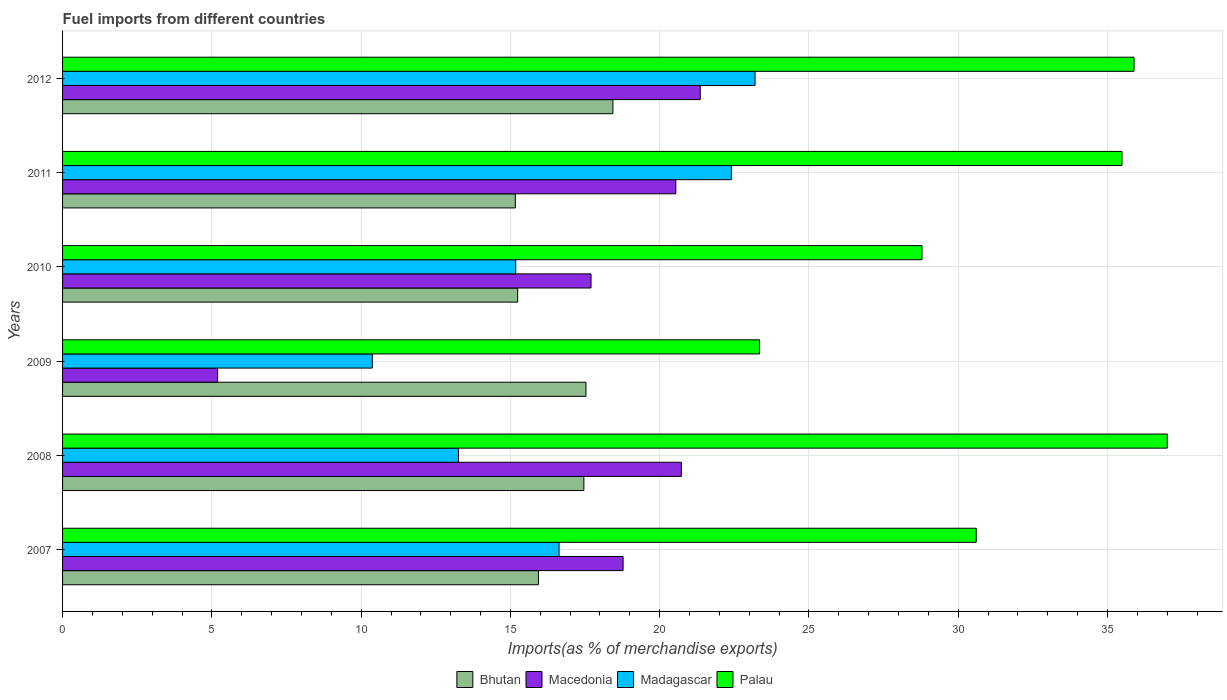Are the number of bars on each tick of the Y-axis equal?
Your answer should be very brief. Yes. In how many cases, is the number of bars for a given year not equal to the number of legend labels?
Offer a very short reply. 0. What is the percentage of imports to different countries in Macedonia in 2012?
Offer a terse response. 21.36. Across all years, what is the maximum percentage of imports to different countries in Bhutan?
Make the answer very short. 18.43. Across all years, what is the minimum percentage of imports to different countries in Bhutan?
Give a very brief answer. 15.16. In which year was the percentage of imports to different countries in Madagascar minimum?
Offer a very short reply. 2009. What is the total percentage of imports to different countries in Madagascar in the graph?
Your response must be concise. 101.04. What is the difference between the percentage of imports to different countries in Madagascar in 2008 and that in 2009?
Provide a short and direct response. 2.89. What is the difference between the percentage of imports to different countries in Bhutan in 2011 and the percentage of imports to different countries in Macedonia in 2012?
Provide a short and direct response. -6.19. What is the average percentage of imports to different countries in Macedonia per year?
Your answer should be compact. 17.38. In the year 2010, what is the difference between the percentage of imports to different countries in Macedonia and percentage of imports to different countries in Madagascar?
Your answer should be compact. 2.52. What is the ratio of the percentage of imports to different countries in Macedonia in 2008 to that in 2010?
Offer a terse response. 1.17. Is the difference between the percentage of imports to different countries in Macedonia in 2009 and 2012 greater than the difference between the percentage of imports to different countries in Madagascar in 2009 and 2012?
Give a very brief answer. No. What is the difference between the highest and the second highest percentage of imports to different countries in Madagascar?
Ensure brevity in your answer.  0.79. What is the difference between the highest and the lowest percentage of imports to different countries in Bhutan?
Offer a very short reply. 3.27. In how many years, is the percentage of imports to different countries in Macedonia greater than the average percentage of imports to different countries in Macedonia taken over all years?
Your response must be concise. 5. Is the sum of the percentage of imports to different countries in Palau in 2008 and 2012 greater than the maximum percentage of imports to different countries in Madagascar across all years?
Your answer should be compact. Yes. Is it the case that in every year, the sum of the percentage of imports to different countries in Bhutan and percentage of imports to different countries in Macedonia is greater than the sum of percentage of imports to different countries in Palau and percentage of imports to different countries in Madagascar?
Your answer should be very brief. No. What does the 2nd bar from the top in 2009 represents?
Your answer should be compact. Madagascar. What does the 4th bar from the bottom in 2009 represents?
Provide a short and direct response. Palau. Is it the case that in every year, the sum of the percentage of imports to different countries in Macedonia and percentage of imports to different countries in Madagascar is greater than the percentage of imports to different countries in Palau?
Offer a very short reply. No. How many bars are there?
Your answer should be very brief. 24. How many years are there in the graph?
Offer a terse response. 6. What is the difference between two consecutive major ticks on the X-axis?
Offer a very short reply. 5. Are the values on the major ticks of X-axis written in scientific E-notation?
Make the answer very short. No. How many legend labels are there?
Your response must be concise. 4. What is the title of the graph?
Make the answer very short. Fuel imports from different countries. Does "Mauritius" appear as one of the legend labels in the graph?
Make the answer very short. No. What is the label or title of the X-axis?
Give a very brief answer. Imports(as % of merchandise exports). What is the label or title of the Y-axis?
Offer a terse response. Years. What is the Imports(as % of merchandise exports) of Bhutan in 2007?
Offer a very short reply. 15.94. What is the Imports(as % of merchandise exports) of Macedonia in 2007?
Give a very brief answer. 18.77. What is the Imports(as % of merchandise exports) in Madagascar in 2007?
Keep it short and to the point. 16.63. What is the Imports(as % of merchandise exports) of Palau in 2007?
Ensure brevity in your answer.  30.6. What is the Imports(as % of merchandise exports) of Bhutan in 2008?
Offer a very short reply. 17.46. What is the Imports(as % of merchandise exports) of Macedonia in 2008?
Ensure brevity in your answer.  20.73. What is the Imports(as % of merchandise exports) of Madagascar in 2008?
Offer a terse response. 13.26. What is the Imports(as % of merchandise exports) of Palau in 2008?
Offer a very short reply. 37. What is the Imports(as % of merchandise exports) in Bhutan in 2009?
Your answer should be very brief. 17.53. What is the Imports(as % of merchandise exports) in Macedonia in 2009?
Offer a terse response. 5.19. What is the Imports(as % of merchandise exports) of Madagascar in 2009?
Offer a terse response. 10.37. What is the Imports(as % of merchandise exports) in Palau in 2009?
Your answer should be compact. 23.34. What is the Imports(as % of merchandise exports) in Bhutan in 2010?
Your answer should be compact. 15.24. What is the Imports(as % of merchandise exports) in Macedonia in 2010?
Give a very brief answer. 17.7. What is the Imports(as % of merchandise exports) of Madagascar in 2010?
Your answer should be very brief. 15.18. What is the Imports(as % of merchandise exports) in Palau in 2010?
Offer a terse response. 28.78. What is the Imports(as % of merchandise exports) of Bhutan in 2011?
Keep it short and to the point. 15.16. What is the Imports(as % of merchandise exports) of Macedonia in 2011?
Your answer should be compact. 20.54. What is the Imports(as % of merchandise exports) of Madagascar in 2011?
Ensure brevity in your answer.  22.4. What is the Imports(as % of merchandise exports) in Palau in 2011?
Offer a very short reply. 35.48. What is the Imports(as % of merchandise exports) in Bhutan in 2012?
Offer a very short reply. 18.43. What is the Imports(as % of merchandise exports) of Macedonia in 2012?
Your response must be concise. 21.36. What is the Imports(as % of merchandise exports) of Madagascar in 2012?
Your answer should be very brief. 23.19. What is the Imports(as % of merchandise exports) in Palau in 2012?
Your answer should be compact. 35.89. Across all years, what is the maximum Imports(as % of merchandise exports) in Bhutan?
Your answer should be very brief. 18.43. Across all years, what is the maximum Imports(as % of merchandise exports) in Macedonia?
Keep it short and to the point. 21.36. Across all years, what is the maximum Imports(as % of merchandise exports) in Madagascar?
Your answer should be compact. 23.19. Across all years, what is the maximum Imports(as % of merchandise exports) in Palau?
Provide a succinct answer. 37. Across all years, what is the minimum Imports(as % of merchandise exports) of Bhutan?
Your answer should be compact. 15.16. Across all years, what is the minimum Imports(as % of merchandise exports) of Macedonia?
Your answer should be compact. 5.19. Across all years, what is the minimum Imports(as % of merchandise exports) in Madagascar?
Keep it short and to the point. 10.37. Across all years, what is the minimum Imports(as % of merchandise exports) of Palau?
Keep it short and to the point. 23.34. What is the total Imports(as % of merchandise exports) in Bhutan in the graph?
Provide a succinct answer. 99.77. What is the total Imports(as % of merchandise exports) of Macedonia in the graph?
Offer a terse response. 104.29. What is the total Imports(as % of merchandise exports) of Madagascar in the graph?
Give a very brief answer. 101.04. What is the total Imports(as % of merchandise exports) in Palau in the graph?
Ensure brevity in your answer.  191.1. What is the difference between the Imports(as % of merchandise exports) in Bhutan in 2007 and that in 2008?
Keep it short and to the point. -1.52. What is the difference between the Imports(as % of merchandise exports) in Macedonia in 2007 and that in 2008?
Your answer should be compact. -1.95. What is the difference between the Imports(as % of merchandise exports) in Madagascar in 2007 and that in 2008?
Your response must be concise. 3.37. What is the difference between the Imports(as % of merchandise exports) in Palau in 2007 and that in 2008?
Provide a succinct answer. -6.4. What is the difference between the Imports(as % of merchandise exports) of Bhutan in 2007 and that in 2009?
Give a very brief answer. -1.59. What is the difference between the Imports(as % of merchandise exports) of Macedonia in 2007 and that in 2009?
Give a very brief answer. 13.58. What is the difference between the Imports(as % of merchandise exports) of Madagascar in 2007 and that in 2009?
Your answer should be very brief. 6.25. What is the difference between the Imports(as % of merchandise exports) in Palau in 2007 and that in 2009?
Your response must be concise. 7.26. What is the difference between the Imports(as % of merchandise exports) of Bhutan in 2007 and that in 2010?
Offer a very short reply. 0.7. What is the difference between the Imports(as % of merchandise exports) in Macedonia in 2007 and that in 2010?
Give a very brief answer. 1.07. What is the difference between the Imports(as % of merchandise exports) of Madagascar in 2007 and that in 2010?
Ensure brevity in your answer.  1.45. What is the difference between the Imports(as % of merchandise exports) of Palau in 2007 and that in 2010?
Offer a very short reply. 1.82. What is the difference between the Imports(as % of merchandise exports) of Bhutan in 2007 and that in 2011?
Make the answer very short. 0.77. What is the difference between the Imports(as % of merchandise exports) in Macedonia in 2007 and that in 2011?
Your answer should be very brief. -1.76. What is the difference between the Imports(as % of merchandise exports) in Madagascar in 2007 and that in 2011?
Offer a terse response. -5.77. What is the difference between the Imports(as % of merchandise exports) of Palau in 2007 and that in 2011?
Ensure brevity in your answer.  -4.88. What is the difference between the Imports(as % of merchandise exports) of Bhutan in 2007 and that in 2012?
Ensure brevity in your answer.  -2.5. What is the difference between the Imports(as % of merchandise exports) of Macedonia in 2007 and that in 2012?
Give a very brief answer. -2.58. What is the difference between the Imports(as % of merchandise exports) of Madagascar in 2007 and that in 2012?
Your response must be concise. -6.56. What is the difference between the Imports(as % of merchandise exports) of Palau in 2007 and that in 2012?
Your answer should be very brief. -5.29. What is the difference between the Imports(as % of merchandise exports) of Bhutan in 2008 and that in 2009?
Offer a terse response. -0.07. What is the difference between the Imports(as % of merchandise exports) of Macedonia in 2008 and that in 2009?
Make the answer very short. 15.53. What is the difference between the Imports(as % of merchandise exports) in Madagascar in 2008 and that in 2009?
Keep it short and to the point. 2.89. What is the difference between the Imports(as % of merchandise exports) of Palau in 2008 and that in 2009?
Your response must be concise. 13.66. What is the difference between the Imports(as % of merchandise exports) in Bhutan in 2008 and that in 2010?
Give a very brief answer. 2.22. What is the difference between the Imports(as % of merchandise exports) in Macedonia in 2008 and that in 2010?
Make the answer very short. 3.03. What is the difference between the Imports(as % of merchandise exports) of Madagascar in 2008 and that in 2010?
Your answer should be very brief. -1.92. What is the difference between the Imports(as % of merchandise exports) in Palau in 2008 and that in 2010?
Provide a succinct answer. 8.21. What is the difference between the Imports(as % of merchandise exports) of Bhutan in 2008 and that in 2011?
Offer a very short reply. 2.3. What is the difference between the Imports(as % of merchandise exports) of Macedonia in 2008 and that in 2011?
Your answer should be very brief. 0.19. What is the difference between the Imports(as % of merchandise exports) of Madagascar in 2008 and that in 2011?
Your answer should be compact. -9.14. What is the difference between the Imports(as % of merchandise exports) of Palau in 2008 and that in 2011?
Ensure brevity in your answer.  1.52. What is the difference between the Imports(as % of merchandise exports) in Bhutan in 2008 and that in 2012?
Provide a short and direct response. -0.97. What is the difference between the Imports(as % of merchandise exports) of Macedonia in 2008 and that in 2012?
Keep it short and to the point. -0.63. What is the difference between the Imports(as % of merchandise exports) in Madagascar in 2008 and that in 2012?
Keep it short and to the point. -9.93. What is the difference between the Imports(as % of merchandise exports) of Palau in 2008 and that in 2012?
Offer a very short reply. 1.11. What is the difference between the Imports(as % of merchandise exports) in Bhutan in 2009 and that in 2010?
Ensure brevity in your answer.  2.29. What is the difference between the Imports(as % of merchandise exports) in Macedonia in 2009 and that in 2010?
Provide a succinct answer. -12.51. What is the difference between the Imports(as % of merchandise exports) in Madagascar in 2009 and that in 2010?
Your answer should be compact. -4.8. What is the difference between the Imports(as % of merchandise exports) of Palau in 2009 and that in 2010?
Your response must be concise. -5.44. What is the difference between the Imports(as % of merchandise exports) in Bhutan in 2009 and that in 2011?
Provide a succinct answer. 2.36. What is the difference between the Imports(as % of merchandise exports) in Macedonia in 2009 and that in 2011?
Ensure brevity in your answer.  -15.35. What is the difference between the Imports(as % of merchandise exports) of Madagascar in 2009 and that in 2011?
Make the answer very short. -12.03. What is the difference between the Imports(as % of merchandise exports) in Palau in 2009 and that in 2011?
Keep it short and to the point. -12.14. What is the difference between the Imports(as % of merchandise exports) of Bhutan in 2009 and that in 2012?
Provide a short and direct response. -0.9. What is the difference between the Imports(as % of merchandise exports) in Macedonia in 2009 and that in 2012?
Provide a short and direct response. -16.16. What is the difference between the Imports(as % of merchandise exports) of Madagascar in 2009 and that in 2012?
Make the answer very short. -12.82. What is the difference between the Imports(as % of merchandise exports) in Palau in 2009 and that in 2012?
Your answer should be very brief. -12.54. What is the difference between the Imports(as % of merchandise exports) in Bhutan in 2010 and that in 2011?
Keep it short and to the point. 0.08. What is the difference between the Imports(as % of merchandise exports) of Macedonia in 2010 and that in 2011?
Provide a short and direct response. -2.84. What is the difference between the Imports(as % of merchandise exports) of Madagascar in 2010 and that in 2011?
Offer a very short reply. -7.22. What is the difference between the Imports(as % of merchandise exports) in Palau in 2010 and that in 2011?
Your response must be concise. -6.7. What is the difference between the Imports(as % of merchandise exports) of Bhutan in 2010 and that in 2012?
Give a very brief answer. -3.19. What is the difference between the Imports(as % of merchandise exports) in Macedonia in 2010 and that in 2012?
Ensure brevity in your answer.  -3.66. What is the difference between the Imports(as % of merchandise exports) of Madagascar in 2010 and that in 2012?
Keep it short and to the point. -8.01. What is the difference between the Imports(as % of merchandise exports) of Palau in 2010 and that in 2012?
Make the answer very short. -7.1. What is the difference between the Imports(as % of merchandise exports) in Bhutan in 2011 and that in 2012?
Provide a succinct answer. -3.27. What is the difference between the Imports(as % of merchandise exports) of Macedonia in 2011 and that in 2012?
Your response must be concise. -0.82. What is the difference between the Imports(as % of merchandise exports) in Madagascar in 2011 and that in 2012?
Keep it short and to the point. -0.79. What is the difference between the Imports(as % of merchandise exports) in Palau in 2011 and that in 2012?
Provide a succinct answer. -0.4. What is the difference between the Imports(as % of merchandise exports) in Bhutan in 2007 and the Imports(as % of merchandise exports) in Macedonia in 2008?
Offer a very short reply. -4.79. What is the difference between the Imports(as % of merchandise exports) in Bhutan in 2007 and the Imports(as % of merchandise exports) in Madagascar in 2008?
Your response must be concise. 2.68. What is the difference between the Imports(as % of merchandise exports) of Bhutan in 2007 and the Imports(as % of merchandise exports) of Palau in 2008?
Give a very brief answer. -21.06. What is the difference between the Imports(as % of merchandise exports) in Macedonia in 2007 and the Imports(as % of merchandise exports) in Madagascar in 2008?
Provide a succinct answer. 5.51. What is the difference between the Imports(as % of merchandise exports) of Macedonia in 2007 and the Imports(as % of merchandise exports) of Palau in 2008?
Offer a very short reply. -18.23. What is the difference between the Imports(as % of merchandise exports) in Madagascar in 2007 and the Imports(as % of merchandise exports) in Palau in 2008?
Give a very brief answer. -20.37. What is the difference between the Imports(as % of merchandise exports) in Bhutan in 2007 and the Imports(as % of merchandise exports) in Macedonia in 2009?
Provide a succinct answer. 10.74. What is the difference between the Imports(as % of merchandise exports) in Bhutan in 2007 and the Imports(as % of merchandise exports) in Madagascar in 2009?
Offer a very short reply. 5.56. What is the difference between the Imports(as % of merchandise exports) in Bhutan in 2007 and the Imports(as % of merchandise exports) in Palau in 2009?
Your response must be concise. -7.41. What is the difference between the Imports(as % of merchandise exports) in Macedonia in 2007 and the Imports(as % of merchandise exports) in Madagascar in 2009?
Provide a succinct answer. 8.4. What is the difference between the Imports(as % of merchandise exports) in Macedonia in 2007 and the Imports(as % of merchandise exports) in Palau in 2009?
Provide a short and direct response. -4.57. What is the difference between the Imports(as % of merchandise exports) of Madagascar in 2007 and the Imports(as % of merchandise exports) of Palau in 2009?
Your answer should be compact. -6.71. What is the difference between the Imports(as % of merchandise exports) in Bhutan in 2007 and the Imports(as % of merchandise exports) in Macedonia in 2010?
Make the answer very short. -1.76. What is the difference between the Imports(as % of merchandise exports) in Bhutan in 2007 and the Imports(as % of merchandise exports) in Madagascar in 2010?
Provide a succinct answer. 0.76. What is the difference between the Imports(as % of merchandise exports) in Bhutan in 2007 and the Imports(as % of merchandise exports) in Palau in 2010?
Give a very brief answer. -12.85. What is the difference between the Imports(as % of merchandise exports) in Macedonia in 2007 and the Imports(as % of merchandise exports) in Madagascar in 2010?
Offer a terse response. 3.6. What is the difference between the Imports(as % of merchandise exports) of Macedonia in 2007 and the Imports(as % of merchandise exports) of Palau in 2010?
Your answer should be compact. -10.01. What is the difference between the Imports(as % of merchandise exports) of Madagascar in 2007 and the Imports(as % of merchandise exports) of Palau in 2010?
Your answer should be very brief. -12.16. What is the difference between the Imports(as % of merchandise exports) in Bhutan in 2007 and the Imports(as % of merchandise exports) in Macedonia in 2011?
Provide a succinct answer. -4.6. What is the difference between the Imports(as % of merchandise exports) of Bhutan in 2007 and the Imports(as % of merchandise exports) of Madagascar in 2011?
Give a very brief answer. -6.46. What is the difference between the Imports(as % of merchandise exports) of Bhutan in 2007 and the Imports(as % of merchandise exports) of Palau in 2011?
Offer a terse response. -19.55. What is the difference between the Imports(as % of merchandise exports) of Macedonia in 2007 and the Imports(as % of merchandise exports) of Madagascar in 2011?
Your answer should be compact. -3.63. What is the difference between the Imports(as % of merchandise exports) in Macedonia in 2007 and the Imports(as % of merchandise exports) in Palau in 2011?
Your answer should be compact. -16.71. What is the difference between the Imports(as % of merchandise exports) of Madagascar in 2007 and the Imports(as % of merchandise exports) of Palau in 2011?
Offer a terse response. -18.85. What is the difference between the Imports(as % of merchandise exports) in Bhutan in 2007 and the Imports(as % of merchandise exports) in Macedonia in 2012?
Make the answer very short. -5.42. What is the difference between the Imports(as % of merchandise exports) of Bhutan in 2007 and the Imports(as % of merchandise exports) of Madagascar in 2012?
Your answer should be very brief. -7.26. What is the difference between the Imports(as % of merchandise exports) of Bhutan in 2007 and the Imports(as % of merchandise exports) of Palau in 2012?
Offer a terse response. -19.95. What is the difference between the Imports(as % of merchandise exports) of Macedonia in 2007 and the Imports(as % of merchandise exports) of Madagascar in 2012?
Give a very brief answer. -4.42. What is the difference between the Imports(as % of merchandise exports) of Macedonia in 2007 and the Imports(as % of merchandise exports) of Palau in 2012?
Offer a terse response. -17.11. What is the difference between the Imports(as % of merchandise exports) of Madagascar in 2007 and the Imports(as % of merchandise exports) of Palau in 2012?
Give a very brief answer. -19.26. What is the difference between the Imports(as % of merchandise exports) of Bhutan in 2008 and the Imports(as % of merchandise exports) of Macedonia in 2009?
Keep it short and to the point. 12.27. What is the difference between the Imports(as % of merchandise exports) of Bhutan in 2008 and the Imports(as % of merchandise exports) of Madagascar in 2009?
Offer a very short reply. 7.09. What is the difference between the Imports(as % of merchandise exports) of Bhutan in 2008 and the Imports(as % of merchandise exports) of Palau in 2009?
Offer a very short reply. -5.88. What is the difference between the Imports(as % of merchandise exports) in Macedonia in 2008 and the Imports(as % of merchandise exports) in Madagascar in 2009?
Your response must be concise. 10.35. What is the difference between the Imports(as % of merchandise exports) of Macedonia in 2008 and the Imports(as % of merchandise exports) of Palau in 2009?
Offer a terse response. -2.62. What is the difference between the Imports(as % of merchandise exports) in Madagascar in 2008 and the Imports(as % of merchandise exports) in Palau in 2009?
Provide a short and direct response. -10.08. What is the difference between the Imports(as % of merchandise exports) of Bhutan in 2008 and the Imports(as % of merchandise exports) of Macedonia in 2010?
Keep it short and to the point. -0.24. What is the difference between the Imports(as % of merchandise exports) in Bhutan in 2008 and the Imports(as % of merchandise exports) in Madagascar in 2010?
Offer a terse response. 2.28. What is the difference between the Imports(as % of merchandise exports) in Bhutan in 2008 and the Imports(as % of merchandise exports) in Palau in 2010?
Provide a succinct answer. -11.32. What is the difference between the Imports(as % of merchandise exports) in Macedonia in 2008 and the Imports(as % of merchandise exports) in Madagascar in 2010?
Provide a succinct answer. 5.55. What is the difference between the Imports(as % of merchandise exports) in Macedonia in 2008 and the Imports(as % of merchandise exports) in Palau in 2010?
Offer a terse response. -8.06. What is the difference between the Imports(as % of merchandise exports) of Madagascar in 2008 and the Imports(as % of merchandise exports) of Palau in 2010?
Provide a short and direct response. -15.52. What is the difference between the Imports(as % of merchandise exports) in Bhutan in 2008 and the Imports(as % of merchandise exports) in Macedonia in 2011?
Offer a very short reply. -3.08. What is the difference between the Imports(as % of merchandise exports) in Bhutan in 2008 and the Imports(as % of merchandise exports) in Madagascar in 2011?
Provide a short and direct response. -4.94. What is the difference between the Imports(as % of merchandise exports) of Bhutan in 2008 and the Imports(as % of merchandise exports) of Palau in 2011?
Your answer should be very brief. -18.02. What is the difference between the Imports(as % of merchandise exports) of Macedonia in 2008 and the Imports(as % of merchandise exports) of Madagascar in 2011?
Give a very brief answer. -1.67. What is the difference between the Imports(as % of merchandise exports) of Macedonia in 2008 and the Imports(as % of merchandise exports) of Palau in 2011?
Provide a short and direct response. -14.76. What is the difference between the Imports(as % of merchandise exports) in Madagascar in 2008 and the Imports(as % of merchandise exports) in Palau in 2011?
Your response must be concise. -22.22. What is the difference between the Imports(as % of merchandise exports) of Bhutan in 2008 and the Imports(as % of merchandise exports) of Macedonia in 2012?
Give a very brief answer. -3.9. What is the difference between the Imports(as % of merchandise exports) of Bhutan in 2008 and the Imports(as % of merchandise exports) of Madagascar in 2012?
Give a very brief answer. -5.73. What is the difference between the Imports(as % of merchandise exports) in Bhutan in 2008 and the Imports(as % of merchandise exports) in Palau in 2012?
Your answer should be compact. -18.43. What is the difference between the Imports(as % of merchandise exports) of Macedonia in 2008 and the Imports(as % of merchandise exports) of Madagascar in 2012?
Offer a terse response. -2.47. What is the difference between the Imports(as % of merchandise exports) in Macedonia in 2008 and the Imports(as % of merchandise exports) in Palau in 2012?
Your answer should be very brief. -15.16. What is the difference between the Imports(as % of merchandise exports) of Madagascar in 2008 and the Imports(as % of merchandise exports) of Palau in 2012?
Ensure brevity in your answer.  -22.63. What is the difference between the Imports(as % of merchandise exports) in Bhutan in 2009 and the Imports(as % of merchandise exports) in Macedonia in 2010?
Offer a terse response. -0.17. What is the difference between the Imports(as % of merchandise exports) in Bhutan in 2009 and the Imports(as % of merchandise exports) in Madagascar in 2010?
Offer a very short reply. 2.35. What is the difference between the Imports(as % of merchandise exports) in Bhutan in 2009 and the Imports(as % of merchandise exports) in Palau in 2010?
Offer a very short reply. -11.26. What is the difference between the Imports(as % of merchandise exports) of Macedonia in 2009 and the Imports(as % of merchandise exports) of Madagascar in 2010?
Ensure brevity in your answer.  -9.98. What is the difference between the Imports(as % of merchandise exports) in Macedonia in 2009 and the Imports(as % of merchandise exports) in Palau in 2010?
Provide a short and direct response. -23.59. What is the difference between the Imports(as % of merchandise exports) of Madagascar in 2009 and the Imports(as % of merchandise exports) of Palau in 2010?
Provide a succinct answer. -18.41. What is the difference between the Imports(as % of merchandise exports) in Bhutan in 2009 and the Imports(as % of merchandise exports) in Macedonia in 2011?
Your answer should be compact. -3.01. What is the difference between the Imports(as % of merchandise exports) of Bhutan in 2009 and the Imports(as % of merchandise exports) of Madagascar in 2011?
Your answer should be compact. -4.87. What is the difference between the Imports(as % of merchandise exports) in Bhutan in 2009 and the Imports(as % of merchandise exports) in Palau in 2011?
Provide a short and direct response. -17.95. What is the difference between the Imports(as % of merchandise exports) of Macedonia in 2009 and the Imports(as % of merchandise exports) of Madagascar in 2011?
Your answer should be compact. -17.21. What is the difference between the Imports(as % of merchandise exports) in Macedonia in 2009 and the Imports(as % of merchandise exports) in Palau in 2011?
Provide a short and direct response. -30.29. What is the difference between the Imports(as % of merchandise exports) of Madagascar in 2009 and the Imports(as % of merchandise exports) of Palau in 2011?
Offer a very short reply. -25.11. What is the difference between the Imports(as % of merchandise exports) of Bhutan in 2009 and the Imports(as % of merchandise exports) of Macedonia in 2012?
Keep it short and to the point. -3.83. What is the difference between the Imports(as % of merchandise exports) of Bhutan in 2009 and the Imports(as % of merchandise exports) of Madagascar in 2012?
Ensure brevity in your answer.  -5.66. What is the difference between the Imports(as % of merchandise exports) of Bhutan in 2009 and the Imports(as % of merchandise exports) of Palau in 2012?
Offer a terse response. -18.36. What is the difference between the Imports(as % of merchandise exports) in Macedonia in 2009 and the Imports(as % of merchandise exports) in Madagascar in 2012?
Your response must be concise. -18. What is the difference between the Imports(as % of merchandise exports) in Macedonia in 2009 and the Imports(as % of merchandise exports) in Palau in 2012?
Provide a short and direct response. -30.69. What is the difference between the Imports(as % of merchandise exports) in Madagascar in 2009 and the Imports(as % of merchandise exports) in Palau in 2012?
Make the answer very short. -25.51. What is the difference between the Imports(as % of merchandise exports) of Bhutan in 2010 and the Imports(as % of merchandise exports) of Macedonia in 2011?
Offer a terse response. -5.3. What is the difference between the Imports(as % of merchandise exports) in Bhutan in 2010 and the Imports(as % of merchandise exports) in Madagascar in 2011?
Offer a terse response. -7.16. What is the difference between the Imports(as % of merchandise exports) in Bhutan in 2010 and the Imports(as % of merchandise exports) in Palau in 2011?
Provide a succinct answer. -20.24. What is the difference between the Imports(as % of merchandise exports) of Macedonia in 2010 and the Imports(as % of merchandise exports) of Madagascar in 2011?
Your answer should be very brief. -4.7. What is the difference between the Imports(as % of merchandise exports) of Macedonia in 2010 and the Imports(as % of merchandise exports) of Palau in 2011?
Provide a short and direct response. -17.78. What is the difference between the Imports(as % of merchandise exports) in Madagascar in 2010 and the Imports(as % of merchandise exports) in Palau in 2011?
Offer a very short reply. -20.3. What is the difference between the Imports(as % of merchandise exports) in Bhutan in 2010 and the Imports(as % of merchandise exports) in Macedonia in 2012?
Your response must be concise. -6.12. What is the difference between the Imports(as % of merchandise exports) of Bhutan in 2010 and the Imports(as % of merchandise exports) of Madagascar in 2012?
Provide a succinct answer. -7.95. What is the difference between the Imports(as % of merchandise exports) of Bhutan in 2010 and the Imports(as % of merchandise exports) of Palau in 2012?
Provide a short and direct response. -20.65. What is the difference between the Imports(as % of merchandise exports) in Macedonia in 2010 and the Imports(as % of merchandise exports) in Madagascar in 2012?
Offer a very short reply. -5.49. What is the difference between the Imports(as % of merchandise exports) of Macedonia in 2010 and the Imports(as % of merchandise exports) of Palau in 2012?
Ensure brevity in your answer.  -18.19. What is the difference between the Imports(as % of merchandise exports) in Madagascar in 2010 and the Imports(as % of merchandise exports) in Palau in 2012?
Your answer should be compact. -20.71. What is the difference between the Imports(as % of merchandise exports) in Bhutan in 2011 and the Imports(as % of merchandise exports) in Macedonia in 2012?
Keep it short and to the point. -6.19. What is the difference between the Imports(as % of merchandise exports) of Bhutan in 2011 and the Imports(as % of merchandise exports) of Madagascar in 2012?
Make the answer very short. -8.03. What is the difference between the Imports(as % of merchandise exports) of Bhutan in 2011 and the Imports(as % of merchandise exports) of Palau in 2012?
Your answer should be very brief. -20.72. What is the difference between the Imports(as % of merchandise exports) in Macedonia in 2011 and the Imports(as % of merchandise exports) in Madagascar in 2012?
Offer a very short reply. -2.65. What is the difference between the Imports(as % of merchandise exports) in Macedonia in 2011 and the Imports(as % of merchandise exports) in Palau in 2012?
Ensure brevity in your answer.  -15.35. What is the difference between the Imports(as % of merchandise exports) in Madagascar in 2011 and the Imports(as % of merchandise exports) in Palau in 2012?
Provide a succinct answer. -13.49. What is the average Imports(as % of merchandise exports) of Bhutan per year?
Offer a terse response. 16.63. What is the average Imports(as % of merchandise exports) in Macedonia per year?
Provide a succinct answer. 17.38. What is the average Imports(as % of merchandise exports) in Madagascar per year?
Your answer should be compact. 16.84. What is the average Imports(as % of merchandise exports) of Palau per year?
Keep it short and to the point. 31.85. In the year 2007, what is the difference between the Imports(as % of merchandise exports) in Bhutan and Imports(as % of merchandise exports) in Macedonia?
Ensure brevity in your answer.  -2.84. In the year 2007, what is the difference between the Imports(as % of merchandise exports) in Bhutan and Imports(as % of merchandise exports) in Madagascar?
Provide a succinct answer. -0.69. In the year 2007, what is the difference between the Imports(as % of merchandise exports) in Bhutan and Imports(as % of merchandise exports) in Palau?
Keep it short and to the point. -14.66. In the year 2007, what is the difference between the Imports(as % of merchandise exports) of Macedonia and Imports(as % of merchandise exports) of Madagascar?
Make the answer very short. 2.15. In the year 2007, what is the difference between the Imports(as % of merchandise exports) of Macedonia and Imports(as % of merchandise exports) of Palau?
Your response must be concise. -11.83. In the year 2007, what is the difference between the Imports(as % of merchandise exports) of Madagascar and Imports(as % of merchandise exports) of Palau?
Your answer should be very brief. -13.97. In the year 2008, what is the difference between the Imports(as % of merchandise exports) of Bhutan and Imports(as % of merchandise exports) of Macedonia?
Ensure brevity in your answer.  -3.27. In the year 2008, what is the difference between the Imports(as % of merchandise exports) of Bhutan and Imports(as % of merchandise exports) of Madagascar?
Give a very brief answer. 4.2. In the year 2008, what is the difference between the Imports(as % of merchandise exports) in Bhutan and Imports(as % of merchandise exports) in Palau?
Offer a terse response. -19.54. In the year 2008, what is the difference between the Imports(as % of merchandise exports) of Macedonia and Imports(as % of merchandise exports) of Madagascar?
Your response must be concise. 7.47. In the year 2008, what is the difference between the Imports(as % of merchandise exports) in Macedonia and Imports(as % of merchandise exports) in Palau?
Give a very brief answer. -16.27. In the year 2008, what is the difference between the Imports(as % of merchandise exports) in Madagascar and Imports(as % of merchandise exports) in Palau?
Offer a very short reply. -23.74. In the year 2009, what is the difference between the Imports(as % of merchandise exports) of Bhutan and Imports(as % of merchandise exports) of Macedonia?
Offer a very short reply. 12.34. In the year 2009, what is the difference between the Imports(as % of merchandise exports) of Bhutan and Imports(as % of merchandise exports) of Madagascar?
Your answer should be very brief. 7.15. In the year 2009, what is the difference between the Imports(as % of merchandise exports) of Bhutan and Imports(as % of merchandise exports) of Palau?
Your answer should be very brief. -5.81. In the year 2009, what is the difference between the Imports(as % of merchandise exports) of Macedonia and Imports(as % of merchandise exports) of Madagascar?
Offer a very short reply. -5.18. In the year 2009, what is the difference between the Imports(as % of merchandise exports) in Macedonia and Imports(as % of merchandise exports) in Palau?
Keep it short and to the point. -18.15. In the year 2009, what is the difference between the Imports(as % of merchandise exports) of Madagascar and Imports(as % of merchandise exports) of Palau?
Keep it short and to the point. -12.97. In the year 2010, what is the difference between the Imports(as % of merchandise exports) of Bhutan and Imports(as % of merchandise exports) of Macedonia?
Your response must be concise. -2.46. In the year 2010, what is the difference between the Imports(as % of merchandise exports) of Bhutan and Imports(as % of merchandise exports) of Madagascar?
Your answer should be very brief. 0.06. In the year 2010, what is the difference between the Imports(as % of merchandise exports) in Bhutan and Imports(as % of merchandise exports) in Palau?
Offer a very short reply. -13.54. In the year 2010, what is the difference between the Imports(as % of merchandise exports) in Macedonia and Imports(as % of merchandise exports) in Madagascar?
Ensure brevity in your answer.  2.52. In the year 2010, what is the difference between the Imports(as % of merchandise exports) in Macedonia and Imports(as % of merchandise exports) in Palau?
Give a very brief answer. -11.08. In the year 2010, what is the difference between the Imports(as % of merchandise exports) in Madagascar and Imports(as % of merchandise exports) in Palau?
Your response must be concise. -13.61. In the year 2011, what is the difference between the Imports(as % of merchandise exports) of Bhutan and Imports(as % of merchandise exports) of Macedonia?
Provide a short and direct response. -5.37. In the year 2011, what is the difference between the Imports(as % of merchandise exports) in Bhutan and Imports(as % of merchandise exports) in Madagascar?
Give a very brief answer. -7.24. In the year 2011, what is the difference between the Imports(as % of merchandise exports) of Bhutan and Imports(as % of merchandise exports) of Palau?
Make the answer very short. -20.32. In the year 2011, what is the difference between the Imports(as % of merchandise exports) of Macedonia and Imports(as % of merchandise exports) of Madagascar?
Your response must be concise. -1.86. In the year 2011, what is the difference between the Imports(as % of merchandise exports) of Macedonia and Imports(as % of merchandise exports) of Palau?
Provide a short and direct response. -14.94. In the year 2011, what is the difference between the Imports(as % of merchandise exports) in Madagascar and Imports(as % of merchandise exports) in Palau?
Give a very brief answer. -13.08. In the year 2012, what is the difference between the Imports(as % of merchandise exports) of Bhutan and Imports(as % of merchandise exports) of Macedonia?
Give a very brief answer. -2.92. In the year 2012, what is the difference between the Imports(as % of merchandise exports) in Bhutan and Imports(as % of merchandise exports) in Madagascar?
Ensure brevity in your answer.  -4.76. In the year 2012, what is the difference between the Imports(as % of merchandise exports) in Bhutan and Imports(as % of merchandise exports) in Palau?
Offer a terse response. -17.45. In the year 2012, what is the difference between the Imports(as % of merchandise exports) in Macedonia and Imports(as % of merchandise exports) in Madagascar?
Your answer should be very brief. -1.84. In the year 2012, what is the difference between the Imports(as % of merchandise exports) in Macedonia and Imports(as % of merchandise exports) in Palau?
Give a very brief answer. -14.53. In the year 2012, what is the difference between the Imports(as % of merchandise exports) of Madagascar and Imports(as % of merchandise exports) of Palau?
Your response must be concise. -12.69. What is the ratio of the Imports(as % of merchandise exports) of Bhutan in 2007 to that in 2008?
Provide a short and direct response. 0.91. What is the ratio of the Imports(as % of merchandise exports) in Macedonia in 2007 to that in 2008?
Make the answer very short. 0.91. What is the ratio of the Imports(as % of merchandise exports) of Madagascar in 2007 to that in 2008?
Your answer should be compact. 1.25. What is the ratio of the Imports(as % of merchandise exports) of Palau in 2007 to that in 2008?
Ensure brevity in your answer.  0.83. What is the ratio of the Imports(as % of merchandise exports) in Bhutan in 2007 to that in 2009?
Offer a terse response. 0.91. What is the ratio of the Imports(as % of merchandise exports) in Macedonia in 2007 to that in 2009?
Provide a short and direct response. 3.62. What is the ratio of the Imports(as % of merchandise exports) in Madagascar in 2007 to that in 2009?
Ensure brevity in your answer.  1.6. What is the ratio of the Imports(as % of merchandise exports) in Palau in 2007 to that in 2009?
Provide a short and direct response. 1.31. What is the ratio of the Imports(as % of merchandise exports) of Bhutan in 2007 to that in 2010?
Offer a very short reply. 1.05. What is the ratio of the Imports(as % of merchandise exports) in Macedonia in 2007 to that in 2010?
Ensure brevity in your answer.  1.06. What is the ratio of the Imports(as % of merchandise exports) in Madagascar in 2007 to that in 2010?
Provide a succinct answer. 1.1. What is the ratio of the Imports(as % of merchandise exports) in Palau in 2007 to that in 2010?
Provide a succinct answer. 1.06. What is the ratio of the Imports(as % of merchandise exports) in Bhutan in 2007 to that in 2011?
Give a very brief answer. 1.05. What is the ratio of the Imports(as % of merchandise exports) in Macedonia in 2007 to that in 2011?
Make the answer very short. 0.91. What is the ratio of the Imports(as % of merchandise exports) in Madagascar in 2007 to that in 2011?
Make the answer very short. 0.74. What is the ratio of the Imports(as % of merchandise exports) in Palau in 2007 to that in 2011?
Make the answer very short. 0.86. What is the ratio of the Imports(as % of merchandise exports) of Bhutan in 2007 to that in 2012?
Your response must be concise. 0.86. What is the ratio of the Imports(as % of merchandise exports) in Macedonia in 2007 to that in 2012?
Your answer should be compact. 0.88. What is the ratio of the Imports(as % of merchandise exports) of Madagascar in 2007 to that in 2012?
Ensure brevity in your answer.  0.72. What is the ratio of the Imports(as % of merchandise exports) in Palau in 2007 to that in 2012?
Offer a terse response. 0.85. What is the ratio of the Imports(as % of merchandise exports) in Macedonia in 2008 to that in 2009?
Give a very brief answer. 3.99. What is the ratio of the Imports(as % of merchandise exports) of Madagascar in 2008 to that in 2009?
Offer a terse response. 1.28. What is the ratio of the Imports(as % of merchandise exports) of Palau in 2008 to that in 2009?
Offer a terse response. 1.58. What is the ratio of the Imports(as % of merchandise exports) of Bhutan in 2008 to that in 2010?
Provide a succinct answer. 1.15. What is the ratio of the Imports(as % of merchandise exports) of Macedonia in 2008 to that in 2010?
Make the answer very short. 1.17. What is the ratio of the Imports(as % of merchandise exports) of Madagascar in 2008 to that in 2010?
Keep it short and to the point. 0.87. What is the ratio of the Imports(as % of merchandise exports) of Palau in 2008 to that in 2010?
Your answer should be compact. 1.29. What is the ratio of the Imports(as % of merchandise exports) in Bhutan in 2008 to that in 2011?
Ensure brevity in your answer.  1.15. What is the ratio of the Imports(as % of merchandise exports) in Macedonia in 2008 to that in 2011?
Your answer should be very brief. 1.01. What is the ratio of the Imports(as % of merchandise exports) in Madagascar in 2008 to that in 2011?
Your answer should be compact. 0.59. What is the ratio of the Imports(as % of merchandise exports) of Palau in 2008 to that in 2011?
Make the answer very short. 1.04. What is the ratio of the Imports(as % of merchandise exports) in Bhutan in 2008 to that in 2012?
Your answer should be compact. 0.95. What is the ratio of the Imports(as % of merchandise exports) in Macedonia in 2008 to that in 2012?
Ensure brevity in your answer.  0.97. What is the ratio of the Imports(as % of merchandise exports) in Madagascar in 2008 to that in 2012?
Make the answer very short. 0.57. What is the ratio of the Imports(as % of merchandise exports) of Palau in 2008 to that in 2012?
Offer a very short reply. 1.03. What is the ratio of the Imports(as % of merchandise exports) of Bhutan in 2009 to that in 2010?
Offer a very short reply. 1.15. What is the ratio of the Imports(as % of merchandise exports) in Macedonia in 2009 to that in 2010?
Your answer should be very brief. 0.29. What is the ratio of the Imports(as % of merchandise exports) of Madagascar in 2009 to that in 2010?
Provide a short and direct response. 0.68. What is the ratio of the Imports(as % of merchandise exports) of Palau in 2009 to that in 2010?
Your answer should be very brief. 0.81. What is the ratio of the Imports(as % of merchandise exports) in Bhutan in 2009 to that in 2011?
Provide a short and direct response. 1.16. What is the ratio of the Imports(as % of merchandise exports) in Macedonia in 2009 to that in 2011?
Your response must be concise. 0.25. What is the ratio of the Imports(as % of merchandise exports) in Madagascar in 2009 to that in 2011?
Keep it short and to the point. 0.46. What is the ratio of the Imports(as % of merchandise exports) in Palau in 2009 to that in 2011?
Keep it short and to the point. 0.66. What is the ratio of the Imports(as % of merchandise exports) of Bhutan in 2009 to that in 2012?
Make the answer very short. 0.95. What is the ratio of the Imports(as % of merchandise exports) of Macedonia in 2009 to that in 2012?
Give a very brief answer. 0.24. What is the ratio of the Imports(as % of merchandise exports) in Madagascar in 2009 to that in 2012?
Your answer should be very brief. 0.45. What is the ratio of the Imports(as % of merchandise exports) of Palau in 2009 to that in 2012?
Make the answer very short. 0.65. What is the ratio of the Imports(as % of merchandise exports) of Bhutan in 2010 to that in 2011?
Give a very brief answer. 1.01. What is the ratio of the Imports(as % of merchandise exports) of Macedonia in 2010 to that in 2011?
Your answer should be compact. 0.86. What is the ratio of the Imports(as % of merchandise exports) of Madagascar in 2010 to that in 2011?
Provide a short and direct response. 0.68. What is the ratio of the Imports(as % of merchandise exports) in Palau in 2010 to that in 2011?
Offer a terse response. 0.81. What is the ratio of the Imports(as % of merchandise exports) of Bhutan in 2010 to that in 2012?
Your response must be concise. 0.83. What is the ratio of the Imports(as % of merchandise exports) of Macedonia in 2010 to that in 2012?
Offer a very short reply. 0.83. What is the ratio of the Imports(as % of merchandise exports) of Madagascar in 2010 to that in 2012?
Your response must be concise. 0.65. What is the ratio of the Imports(as % of merchandise exports) in Palau in 2010 to that in 2012?
Provide a short and direct response. 0.8. What is the ratio of the Imports(as % of merchandise exports) of Bhutan in 2011 to that in 2012?
Give a very brief answer. 0.82. What is the ratio of the Imports(as % of merchandise exports) in Macedonia in 2011 to that in 2012?
Your response must be concise. 0.96. What is the ratio of the Imports(as % of merchandise exports) in Madagascar in 2011 to that in 2012?
Give a very brief answer. 0.97. What is the ratio of the Imports(as % of merchandise exports) in Palau in 2011 to that in 2012?
Give a very brief answer. 0.99. What is the difference between the highest and the second highest Imports(as % of merchandise exports) of Bhutan?
Provide a succinct answer. 0.9. What is the difference between the highest and the second highest Imports(as % of merchandise exports) of Macedonia?
Give a very brief answer. 0.63. What is the difference between the highest and the second highest Imports(as % of merchandise exports) of Madagascar?
Keep it short and to the point. 0.79. What is the difference between the highest and the second highest Imports(as % of merchandise exports) in Palau?
Give a very brief answer. 1.11. What is the difference between the highest and the lowest Imports(as % of merchandise exports) in Bhutan?
Keep it short and to the point. 3.27. What is the difference between the highest and the lowest Imports(as % of merchandise exports) of Macedonia?
Your response must be concise. 16.16. What is the difference between the highest and the lowest Imports(as % of merchandise exports) of Madagascar?
Offer a very short reply. 12.82. What is the difference between the highest and the lowest Imports(as % of merchandise exports) of Palau?
Your answer should be very brief. 13.66. 